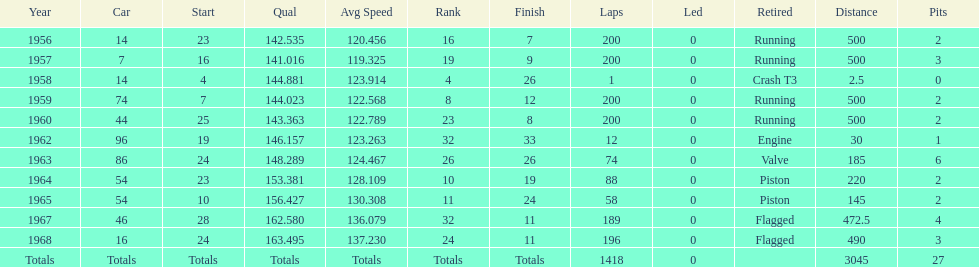Help me parse the entirety of this table. {'header': ['Year', 'Car', 'Start', 'Qual', 'Avg Speed', 'Rank', 'Finish', 'Laps', 'Led', 'Retired', 'Distance', 'Pits'], 'rows': [['1956', '14', '23', '142.535', '120.456', '16', '7', '200', '0', 'Running', '500', '2'], ['1957', '7', '16', '141.016', '119.325', '19', '9', '200', '0', 'Running', '500', '3'], ['1958', '14', '4', '144.881', '123.914', '4', '26', '1', '0', 'Crash T3', '2.5', '0'], ['1959', '74', '7', '144.023', '122.568', '8', '12', '200', '0', 'Running', '500', '2'], ['1960', '44', '25', '143.363', '122.789', '23', '8', '200', '0', 'Running', '500', '2'], ['1962', '96', '19', '146.157', '123.263', '32', '33', '12', '0', 'Engine', '30', '1'], ['1963', '86', '24', '148.289', '124.467', '26', '26', '74', '0', 'Valve', '185', '6'], ['1964', '54', '23', '153.381', '128.109', '10', '19', '88', '0', 'Piston', '220', '2'], ['1965', '54', '10', '156.427', '130.308', '11', '24', '58', '0', 'Piston', '145', '2'], ['1967', '46', '28', '162.580', '136.079', '32', '11', '189', '0', 'Flagged', '472.5', '4'], ['1968', '16', '24', '163.495', '137.230', '24', '11', '196', '0', 'Flagged', '490', '3'], ['Totals', 'Totals', 'Totals', 'Totals', 'Totals', 'Totals', 'Totals', '1418', '0', '', '3045', '27']]} What is the larger laps between 1963 or 1968 1968. 